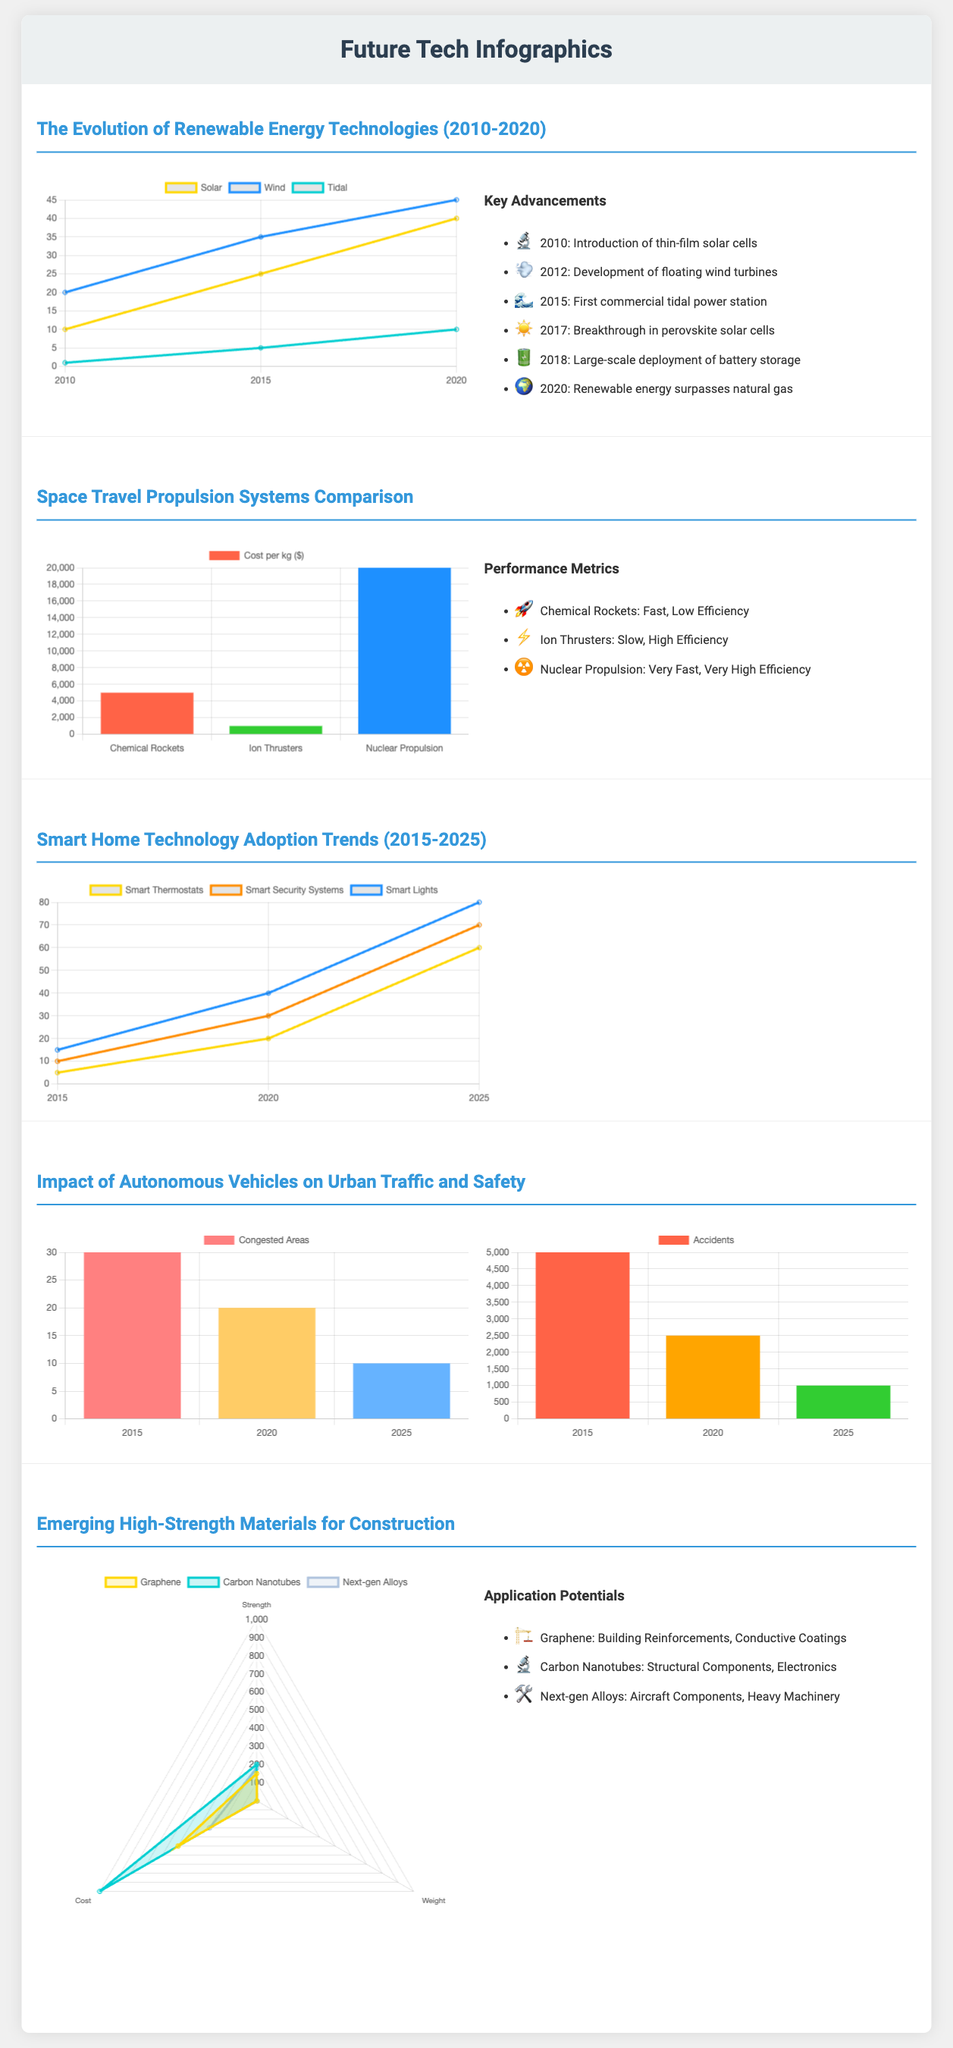What was the first major advancement in solar technology? The first major advancement listed in the infographic is the introduction of thin-film solar cells in 2010.
Answer: Thin-film solar cells Which propulsion system is the most expensive per kilogram? The infographic lists the costs per kilogram of various propulsion systems. Nuclear propulsion costs $20,000 per kg, making it the most expensive.
Answer: Nuclear propulsion What was the adoption rate of smart security systems in 2020? The line graph shows that smart security systems had an adoption rate of 30% in 2020.
Answer: 30% In which year did renewable energy surpass natural gas? The document states that in 2020, renewable energy surpassed natural gas.
Answer: 2020 Which high-strength material has the lowest weight? According to the radar chart, carbon nanotubes have the lowest weight, listed at 1.5.
Answer: 1.5 How much did urban traffic accidents decrease from 2015 to 2025? The infographic indicates that accidents decreased from 5,000 in 2015 to 1,000 in 2025, resulting in a decrease of 4,000.
Answer: 4,000 Which technology showed the highest adoption increase from 2015 to 2025? Smart lights showed an increase from 15% in 2015 to 80% in 2025, the highest increase among the technologies.
Answer: Smart lights What chart type is used to compare emerging high-strength materials? The comparison of high-strength materials is shown using a radar chart.
Answer: Radar chart 